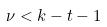Convert formula to latex. <formula><loc_0><loc_0><loc_500><loc_500>\nu < k - t - 1</formula> 